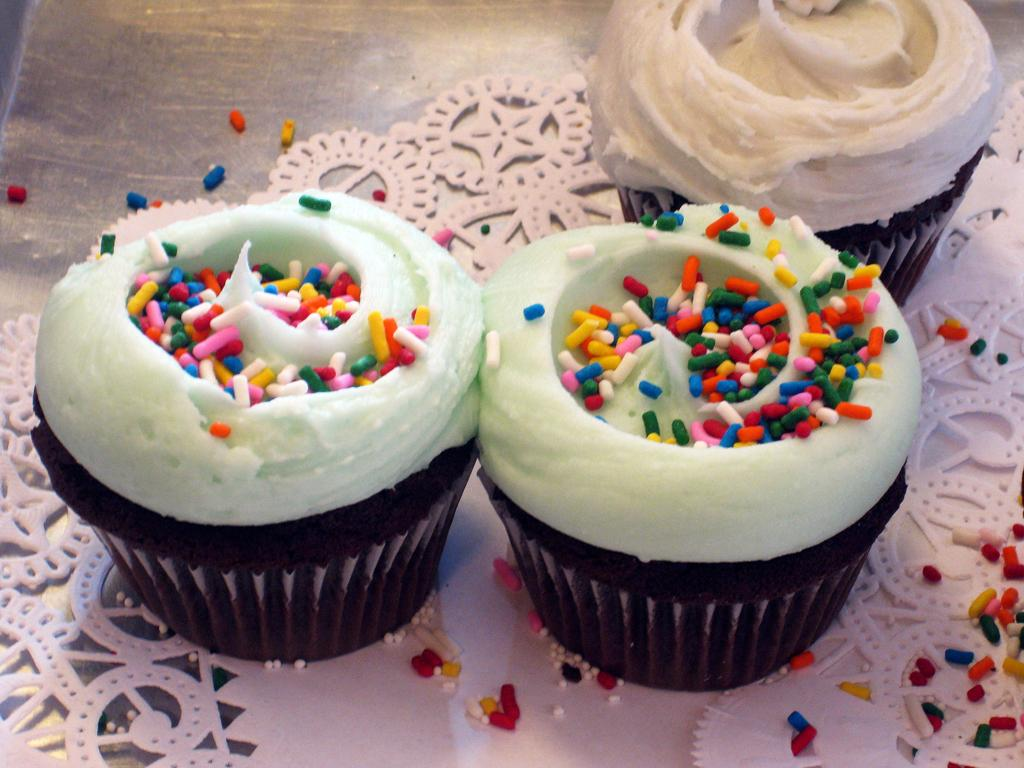What type of dessert can be seen on the left side of the image? There is a cupcake with cream on the left side of the image. How many cupcakes with cream are on the right side of the image? There are two cupcakes with cream on the right side of the image. Where are the cupcakes located in the image? The cupcakes are arranged on a surface. What else can be seen on the surface with the cupcakes? There are additional objects on the surface. What color of paint is being used by the son in the image? There is no son or paint present in the image; it features cupcakes with cream on a surface. 